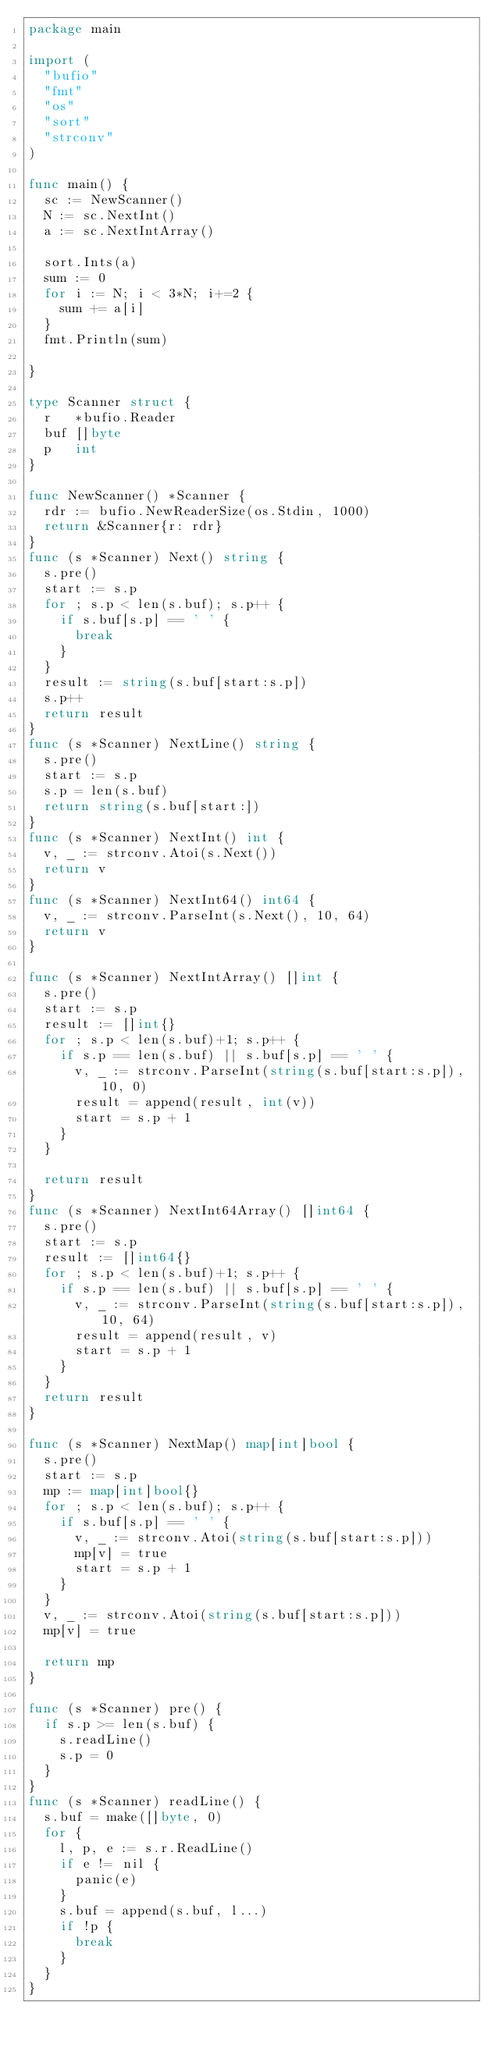<code> <loc_0><loc_0><loc_500><loc_500><_Go_>package main

import (
	"bufio"
	"fmt"
	"os"
	"sort"
	"strconv"
)

func main() {
	sc := NewScanner()
	N := sc.NextInt()
	a := sc.NextIntArray()

	sort.Ints(a)
	sum := 0
	for i := N; i < 3*N; i+=2 {
		sum += a[i]
	}
	fmt.Println(sum)

}

type Scanner struct {
	r   *bufio.Reader
	buf []byte
	p   int
}

func NewScanner() *Scanner {
	rdr := bufio.NewReaderSize(os.Stdin, 1000)
	return &Scanner{r: rdr}
}
func (s *Scanner) Next() string {
	s.pre()
	start := s.p
	for ; s.p < len(s.buf); s.p++ {
		if s.buf[s.p] == ' ' {
			break
		}
	}
	result := string(s.buf[start:s.p])
	s.p++
	return result
}
func (s *Scanner) NextLine() string {
	s.pre()
	start := s.p
	s.p = len(s.buf)
	return string(s.buf[start:])
}
func (s *Scanner) NextInt() int {
	v, _ := strconv.Atoi(s.Next())
	return v
}
func (s *Scanner) NextInt64() int64 {
	v, _ := strconv.ParseInt(s.Next(), 10, 64)
	return v
}

func (s *Scanner) NextIntArray() []int {
	s.pre()
	start := s.p
	result := []int{}
	for ; s.p < len(s.buf)+1; s.p++ {
		if s.p == len(s.buf) || s.buf[s.p] == ' ' {
			v, _ := strconv.ParseInt(string(s.buf[start:s.p]), 10, 0)
			result = append(result, int(v))
			start = s.p + 1
		}
	}

	return result
}
func (s *Scanner) NextInt64Array() []int64 {
	s.pre()
	start := s.p
	result := []int64{}
	for ; s.p < len(s.buf)+1; s.p++ {
		if s.p == len(s.buf) || s.buf[s.p] == ' ' {
			v, _ := strconv.ParseInt(string(s.buf[start:s.p]), 10, 64)
			result = append(result, v)
			start = s.p + 1
		}
	}
	return result
}

func (s *Scanner) NextMap() map[int]bool {
	s.pre()
	start := s.p
	mp := map[int]bool{}
	for ; s.p < len(s.buf); s.p++ {
		if s.buf[s.p] == ' ' {
			v, _ := strconv.Atoi(string(s.buf[start:s.p]))
			mp[v] = true
			start = s.p + 1
		}
	}
	v, _ := strconv.Atoi(string(s.buf[start:s.p]))
	mp[v] = true

	return mp
}

func (s *Scanner) pre() {
	if s.p >= len(s.buf) {
		s.readLine()
		s.p = 0
	}
}
func (s *Scanner) readLine() {
	s.buf = make([]byte, 0)
	for {
		l, p, e := s.r.ReadLine()
		if e != nil {
			panic(e)
		}
		s.buf = append(s.buf, l...)
		if !p {
			break
		}
	}
}
</code> 